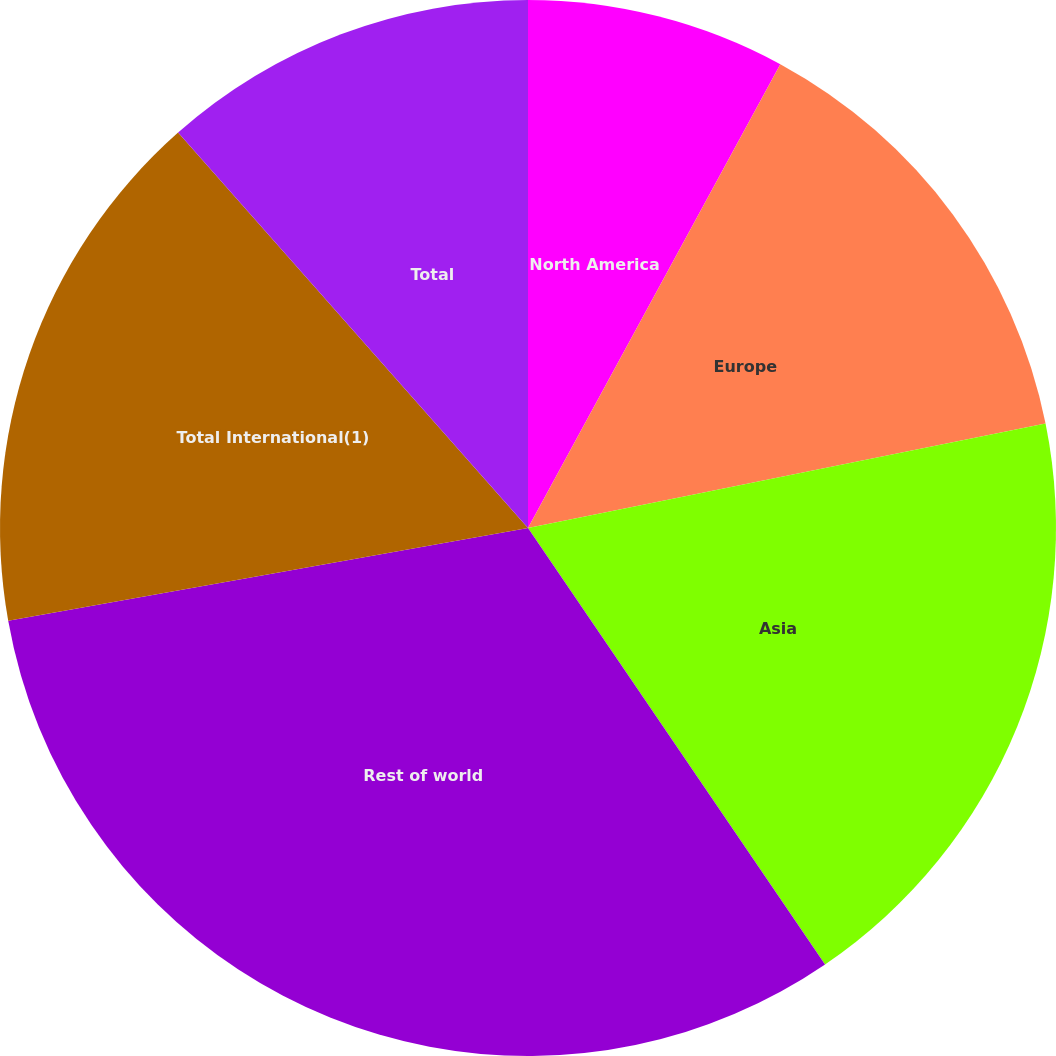<chart> <loc_0><loc_0><loc_500><loc_500><pie_chart><fcel>North America<fcel>Europe<fcel>Asia<fcel>Rest of world<fcel>Total International(1)<fcel>Total<nl><fcel>7.93%<fcel>13.9%<fcel>18.66%<fcel>31.7%<fcel>16.28%<fcel>11.53%<nl></chart> 